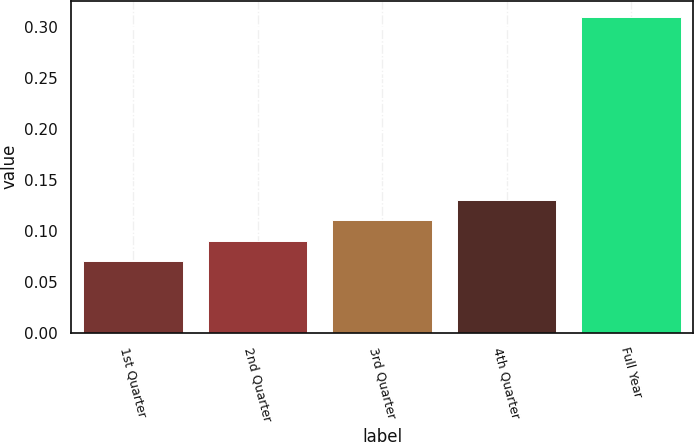Convert chart to OTSL. <chart><loc_0><loc_0><loc_500><loc_500><bar_chart><fcel>1st Quarter<fcel>2nd Quarter<fcel>3rd Quarter<fcel>4th Quarter<fcel>Full Year<nl><fcel>0.07<fcel>0.09<fcel>0.11<fcel>0.13<fcel>0.31<nl></chart> 